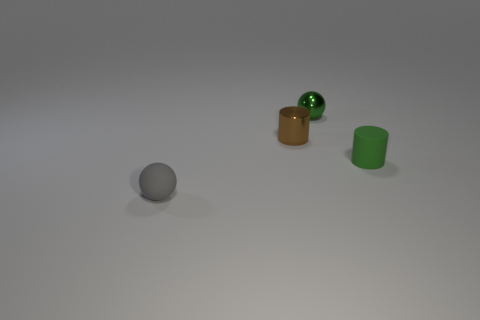Subtract all purple cylinders. Subtract all gray spheres. How many cylinders are left? 2 Add 3 green cylinders. How many objects exist? 7 Add 3 big red balls. How many big red balls exist? 3 Subtract 0 cyan spheres. How many objects are left? 4 Subtract all small cylinders. Subtract all small shiny things. How many objects are left? 0 Add 1 tiny matte cylinders. How many tiny matte cylinders are left? 2 